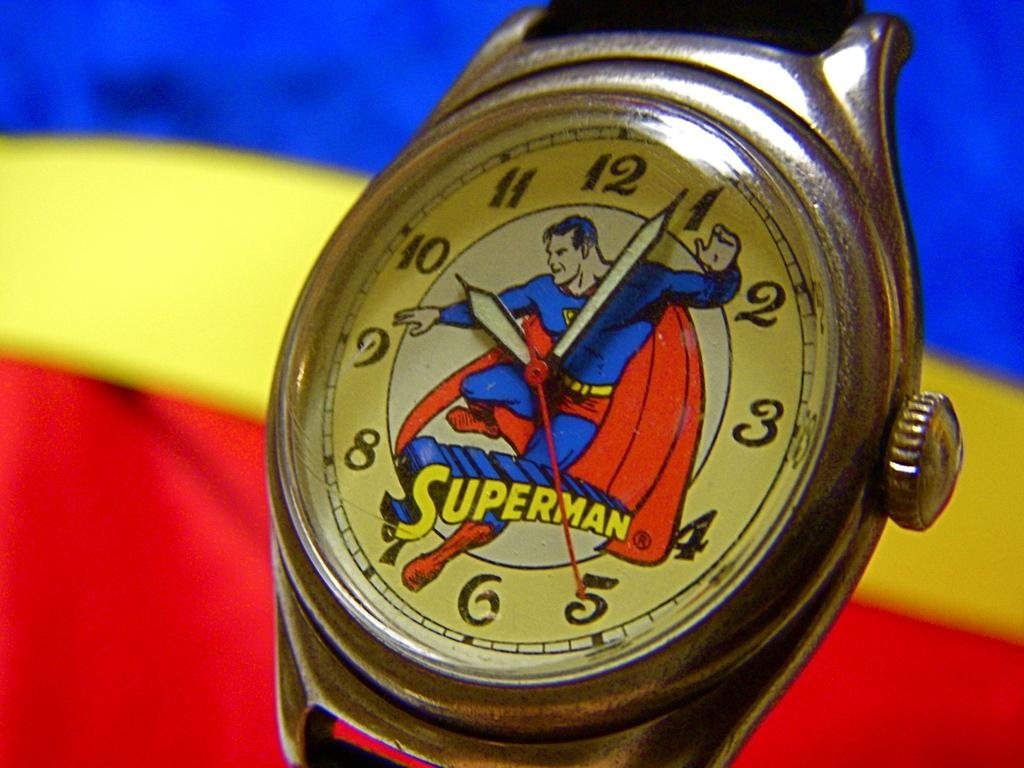<image>
Create a compact narrative representing the image presented. A Superman watch showing that it is 10:04. 